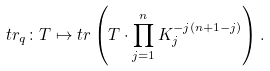<formula> <loc_0><loc_0><loc_500><loc_500>t r _ { q } \colon T \mapsto t r \left ( T \cdot \prod _ { j = 1 } ^ { n } K _ { j } ^ { - j ( n + 1 - j ) } \right ) .</formula> 